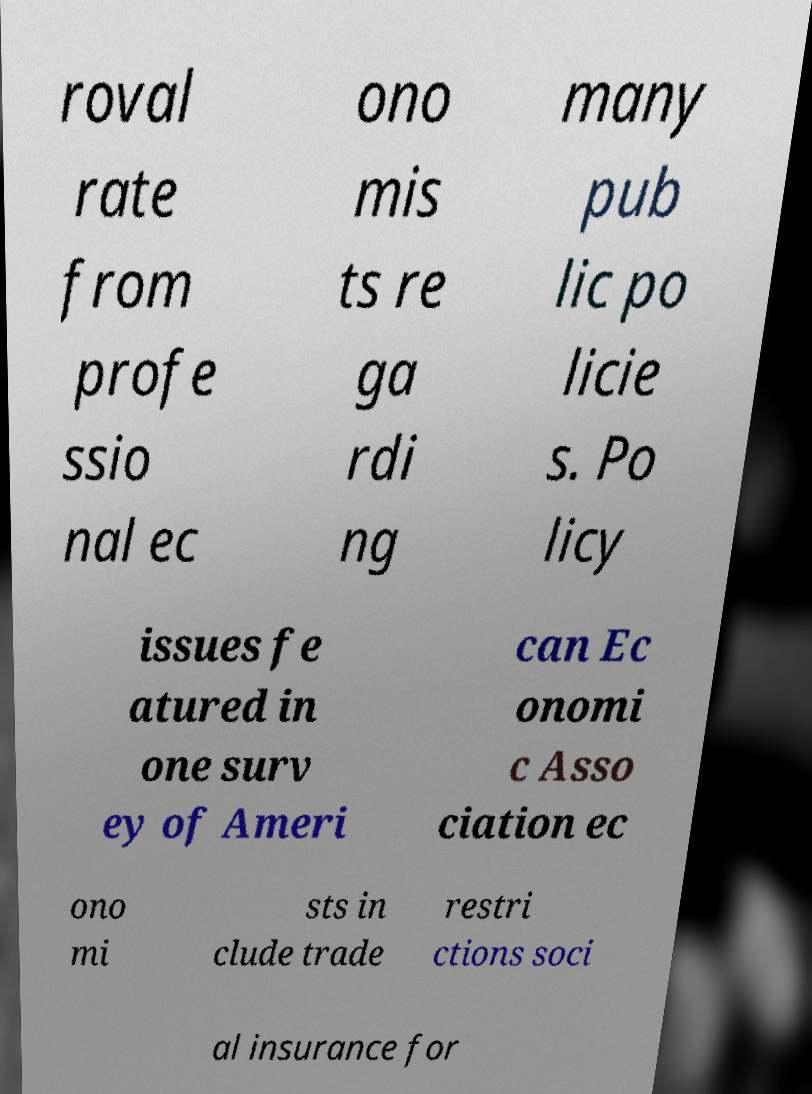Can you read and provide the text displayed in the image?This photo seems to have some interesting text. Can you extract and type it out for me? roval rate from profe ssio nal ec ono mis ts re ga rdi ng many pub lic po licie s. Po licy issues fe atured in one surv ey of Ameri can Ec onomi c Asso ciation ec ono mi sts in clude trade restri ctions soci al insurance for 